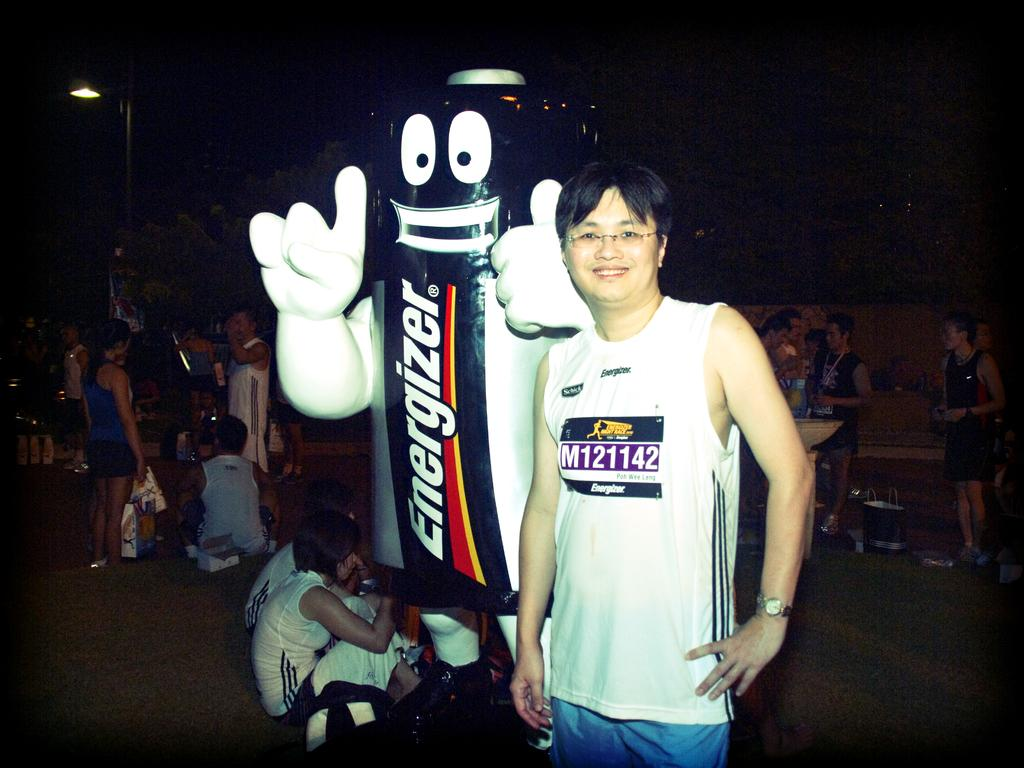<image>
Relay a brief, clear account of the picture shown. A man is standing next to a mascot in an Energizer battery costume. 